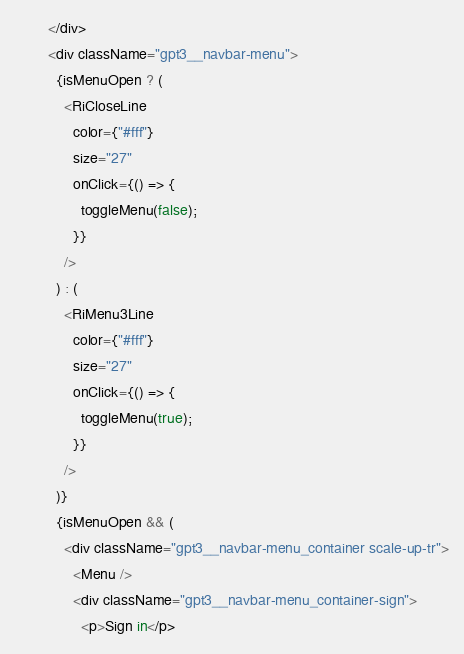Convert code to text. <code><loc_0><loc_0><loc_500><loc_500><_JavaScript_>        </div>
        <div className="gpt3__navbar-menu">
          {isMenuOpen ? (
            <RiCloseLine
              color={"#fff"}
              size="27"
              onClick={() => {
                toggleMenu(false);
              }}
            />
          ) : (
            <RiMenu3Line
              color={"#fff"}
              size="27"
              onClick={() => {
                toggleMenu(true);
              }}
            />
          )}
          {isMenuOpen && (
            <div className="gpt3__navbar-menu_container scale-up-tr">
              <Menu />
              <div className="gpt3__navbar-menu_container-sign">
                <p>Sign in</p></code> 